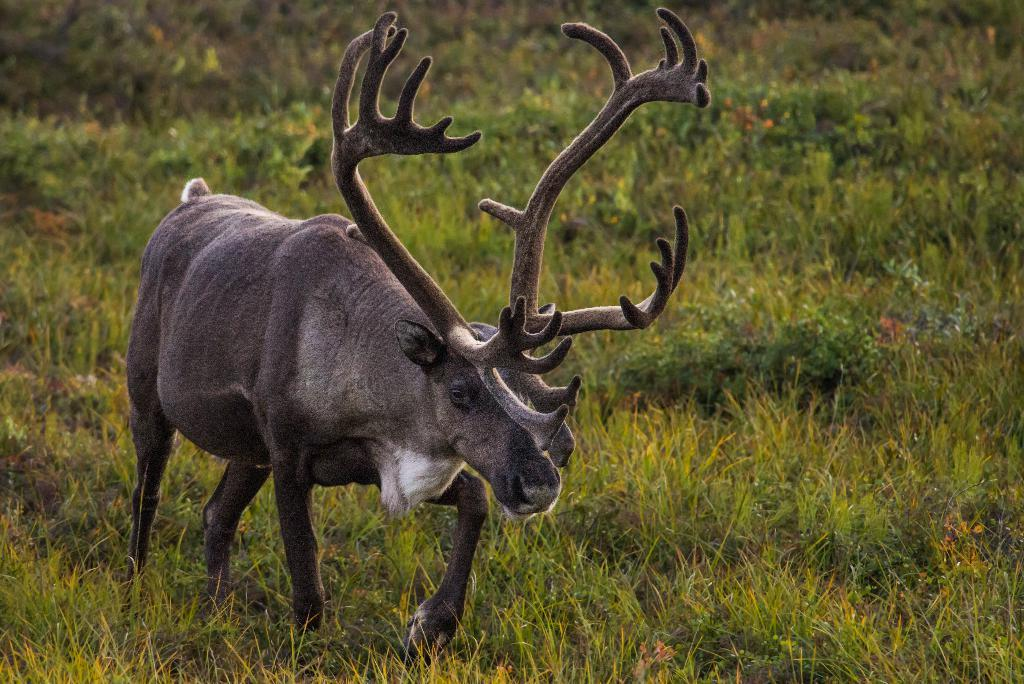What animal is present in the image? There is a deer in the image. Where is the deer located? The deer is on a grassland. What religious symbol can be seen in the image? There is no religious symbol present in the image; it features a deer on a grassland. How many things are present in the image? It is not clear what "things" refers to in this context, but the image features a deer on a grassland. Is there a lamp visible in the image? There is no lamp present in the image; it features a deer on a grassland. 